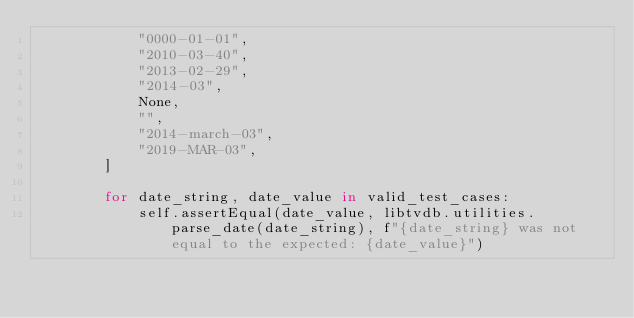<code> <loc_0><loc_0><loc_500><loc_500><_Python_>            "0000-01-01",
            "2010-03-40",
            "2013-02-29",
            "2014-03",
            None,
            "",
            "2014-march-03",
            "2019-MAR-03",
        ]

        for date_string, date_value in valid_test_cases:
            self.assertEqual(date_value, libtvdb.utilities.parse_date(date_string), f"{date_string} was not equal to the expected: {date_value}")
</code> 